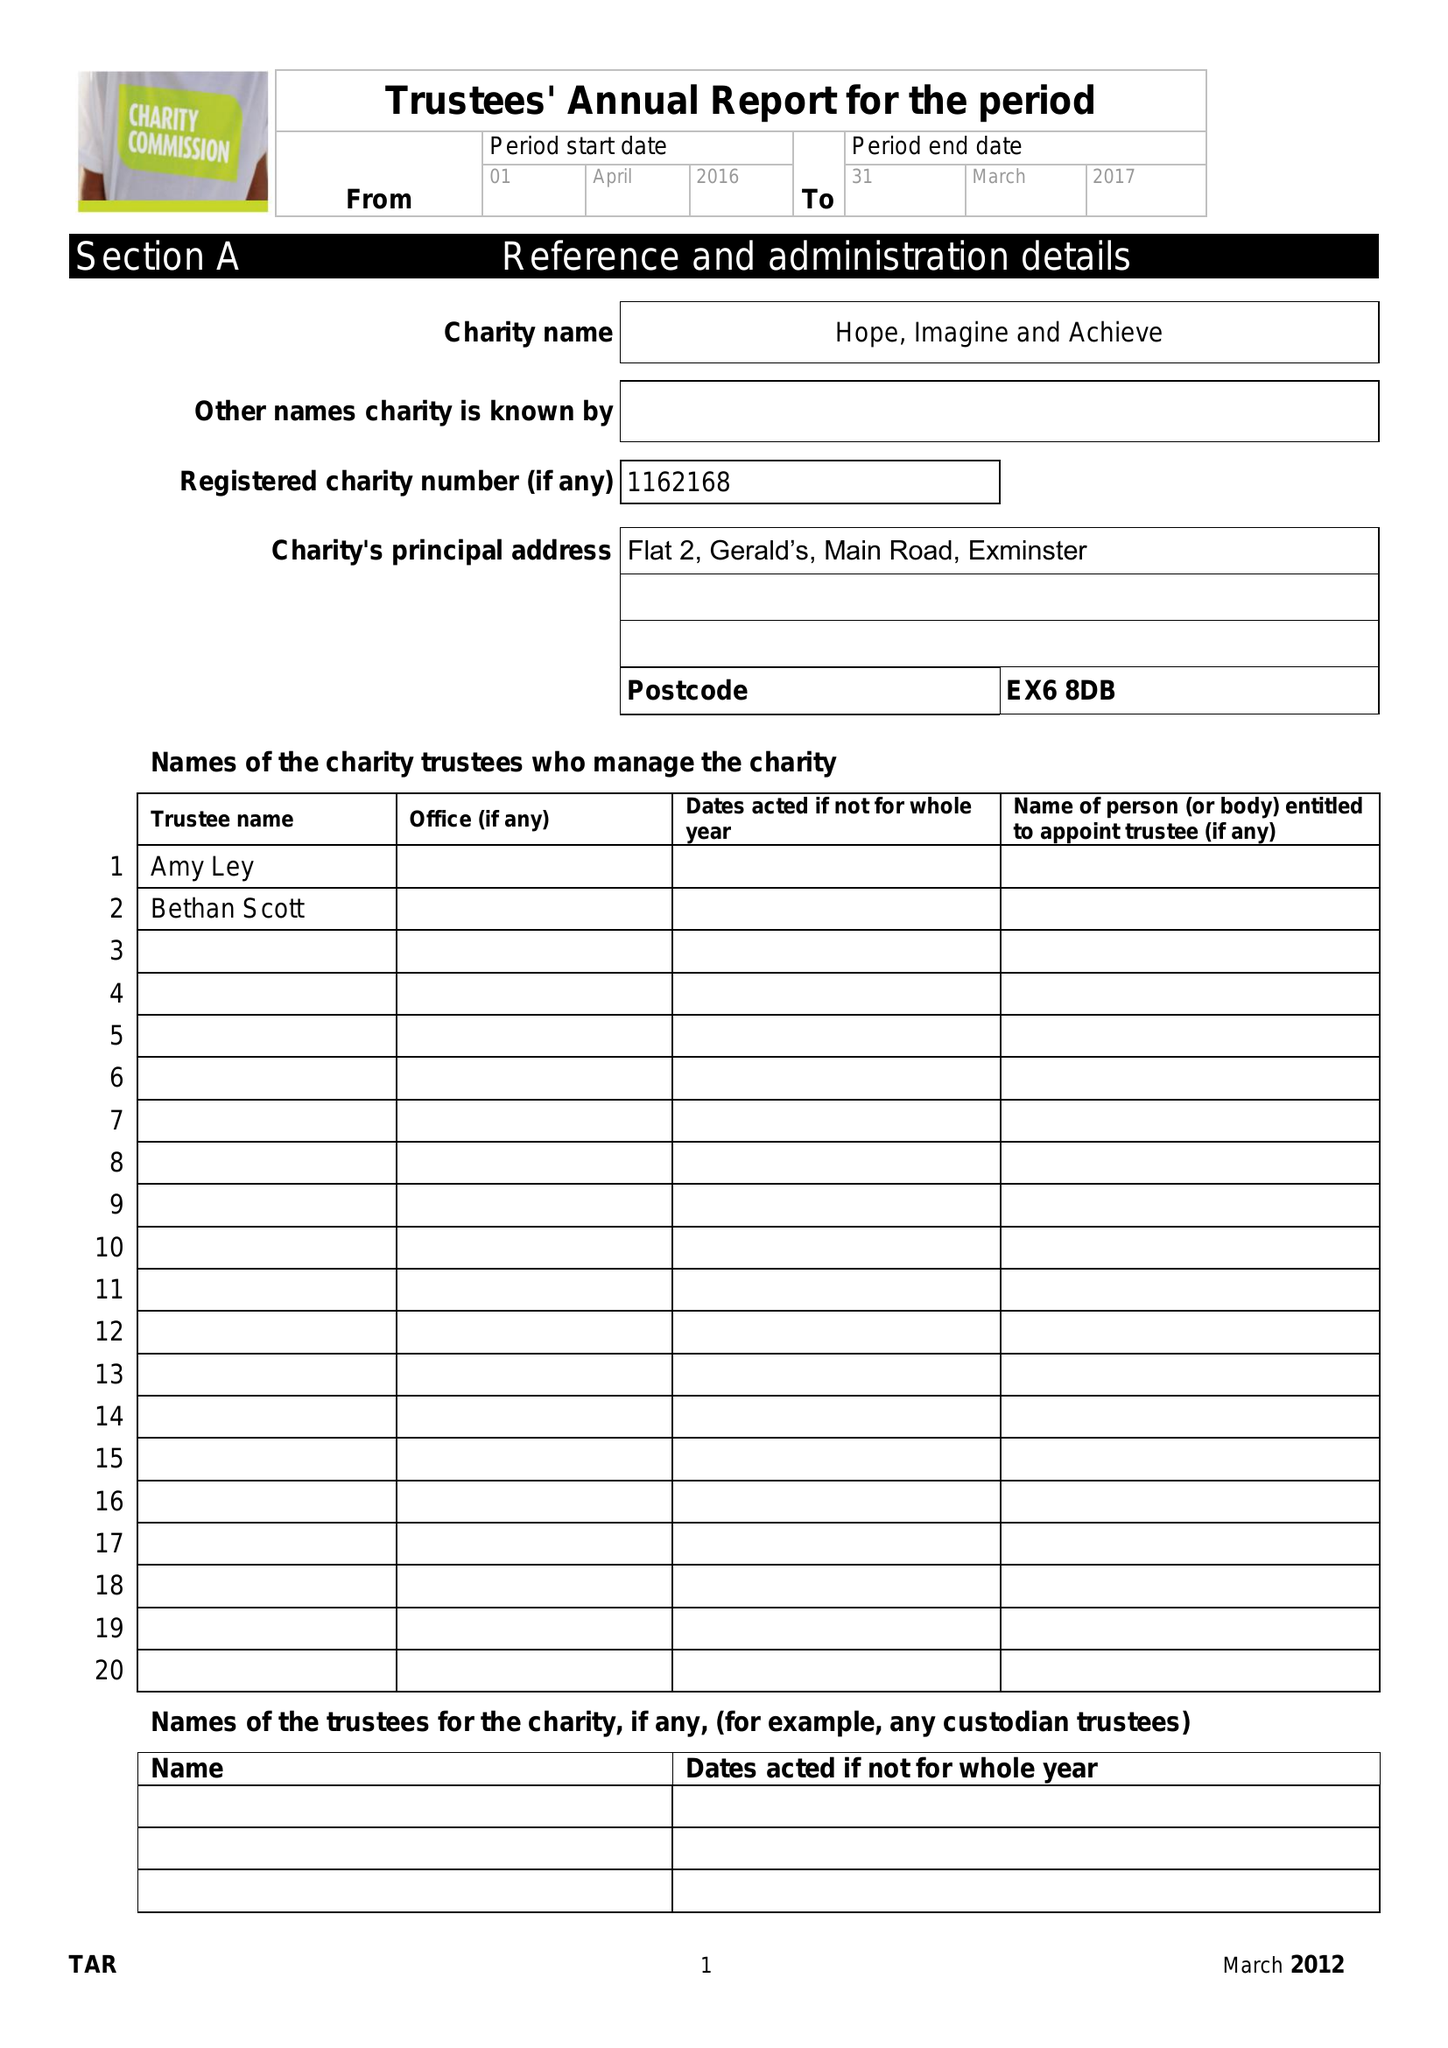What is the value for the address__post_town?
Answer the question using a single word or phrase. EXETER 